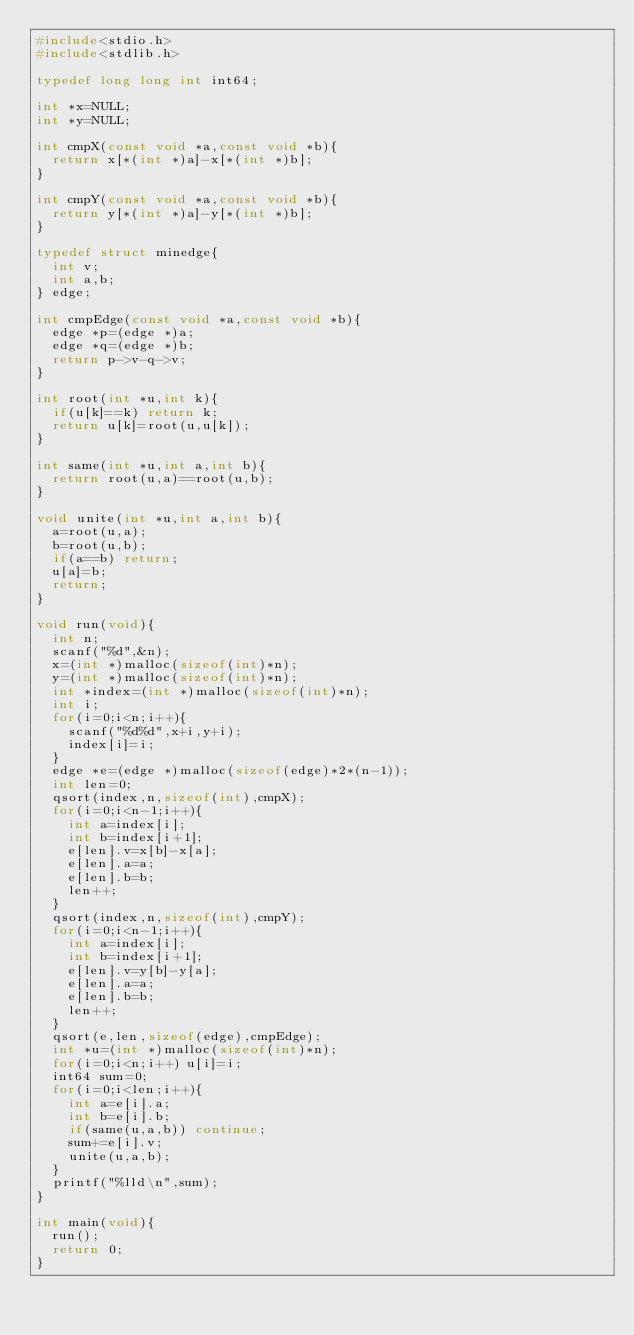Convert code to text. <code><loc_0><loc_0><loc_500><loc_500><_C_>#include<stdio.h>
#include<stdlib.h>

typedef long long int int64;

int *x=NULL;
int *y=NULL;

int cmpX(const void *a,const void *b){
  return x[*(int *)a]-x[*(int *)b];
}

int cmpY(const void *a,const void *b){
  return y[*(int *)a]-y[*(int *)b];
}

typedef struct minedge{
  int v;
  int a,b;
} edge;

int cmpEdge(const void *a,const void *b){
  edge *p=(edge *)a;
  edge *q=(edge *)b;
  return p->v-q->v;
}

int root(int *u,int k){
  if(u[k]==k) return k;
  return u[k]=root(u,u[k]);
}

int same(int *u,int a,int b){
  return root(u,a)==root(u,b);
}

void unite(int *u,int a,int b){
  a=root(u,a);
  b=root(u,b);
  if(a==b) return;
  u[a]=b;
  return;
}

void run(void){
  int n;
  scanf("%d",&n);
  x=(int *)malloc(sizeof(int)*n);
  y=(int *)malloc(sizeof(int)*n);
  int *index=(int *)malloc(sizeof(int)*n);
  int i;
  for(i=0;i<n;i++){
    scanf("%d%d",x+i,y+i);
    index[i]=i;
  }
  edge *e=(edge *)malloc(sizeof(edge)*2*(n-1));
  int len=0;
  qsort(index,n,sizeof(int),cmpX);
  for(i=0;i<n-1;i++){
    int a=index[i];
    int b=index[i+1];
    e[len].v=x[b]-x[a];
    e[len].a=a;
    e[len].b=b;
    len++;
  }
  qsort(index,n,sizeof(int),cmpY);
  for(i=0;i<n-1;i++){
    int a=index[i];
    int b=index[i+1];
    e[len].v=y[b]-y[a];
    e[len].a=a;
    e[len].b=b;
    len++;
  }
  qsort(e,len,sizeof(edge),cmpEdge);
  int *u=(int *)malloc(sizeof(int)*n);
  for(i=0;i<n;i++) u[i]=i;
  int64 sum=0;
  for(i=0;i<len;i++){
    int a=e[i].a;
    int b=e[i].b;
    if(same(u,a,b)) continue;
    sum+=e[i].v;
    unite(u,a,b);
  }
  printf("%lld\n",sum);
}

int main(void){
  run();
  return 0;
}
</code> 